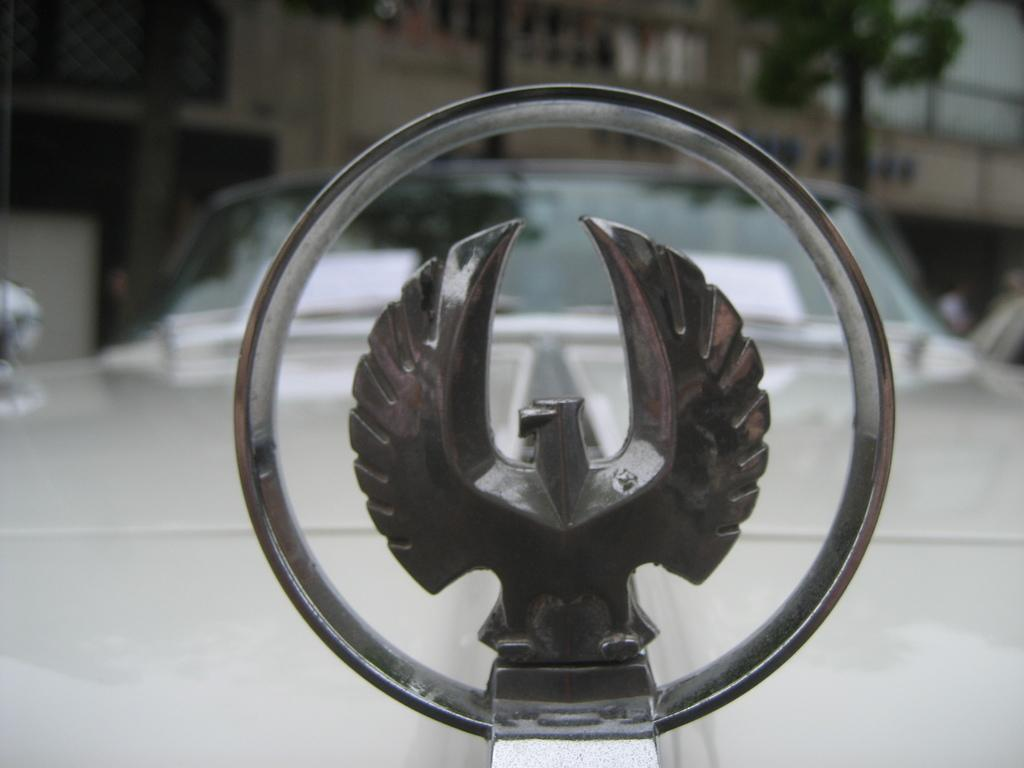What is the main subject in the foreground of the picture? There is a stainless steel design eagle logo in the foreground of the picture. What else can be seen in the foreground of the picture? There is a car in the foreground of the picture. What is visible in the background of the picture? There is a building and trees in the background of the picture. What type of sheet is covering the car in the image? There is no sheet covering the car in the image. How does the turkey contribute to the acoustics in the image? There is no turkey present in the image, so it cannot contribute to the acoustics. 